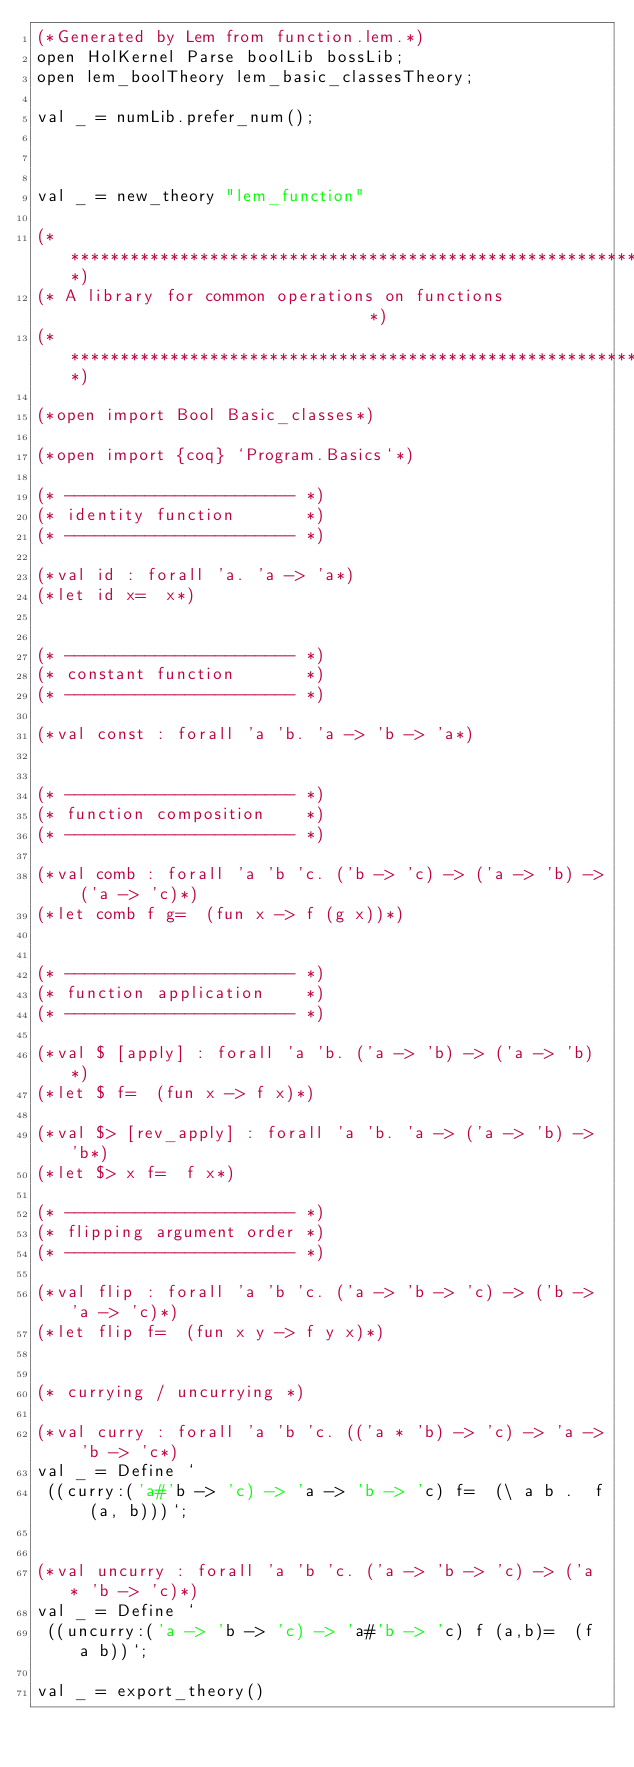<code> <loc_0><loc_0><loc_500><loc_500><_SML_>(*Generated by Lem from function.lem.*)
open HolKernel Parse boolLib bossLib;
open lem_boolTheory lem_basic_classesTheory;

val _ = numLib.prefer_num();



val _ = new_theory "lem_function"

(******************************************************************************)
(* A library for common operations on functions                               *)
(******************************************************************************)

(*open import Bool Basic_classes*)

(*open import {coq} `Program.Basics`*)

(* ----------------------- *)
(* identity function       *)
(* ----------------------- *)

(*val id : forall 'a. 'a -> 'a*)
(*let id x=  x*)


(* ----------------------- *)
(* constant function       *)
(* ----------------------- *)

(*val const : forall 'a 'b. 'a -> 'b -> 'a*)


(* ----------------------- *)
(* function composition    *)
(* ----------------------- *)

(*val comb : forall 'a 'b 'c. ('b -> 'c) -> ('a -> 'b) -> ('a -> 'c)*)
(*let comb f g=  (fun x -> f (g x))*)


(* ----------------------- *)
(* function application    *)
(* ----------------------- *)

(*val $ [apply] : forall 'a 'b. ('a -> 'b) -> ('a -> 'b)*)
(*let $ f=  (fun x -> f x)*)

(*val $> [rev_apply] : forall 'a 'b. 'a -> ('a -> 'b) -> 'b*)
(*let $> x f=  f x*)

(* ----------------------- *)
(* flipping argument order *)
(* ----------------------- *)

(*val flip : forall 'a 'b 'c. ('a -> 'b -> 'c) -> ('b -> 'a -> 'c)*)
(*let flip f=  (fun x y -> f y x)*)


(* currying / uncurrying *)

(*val curry : forall 'a 'b 'c. (('a * 'b) -> 'c) -> 'a -> 'b -> 'c*)
val _ = Define `
 ((curry:('a#'b -> 'c) -> 'a -> 'b -> 'c) f=  (\ a b .  f (a, b)))`;


(*val uncurry : forall 'a 'b 'c. ('a -> 'b -> 'c) -> ('a * 'b -> 'c)*)
val _ = Define `
 ((uncurry:('a -> 'b -> 'c) -> 'a#'b -> 'c) f (a,b)=  (f a b))`;

val _ = export_theory()

</code> 